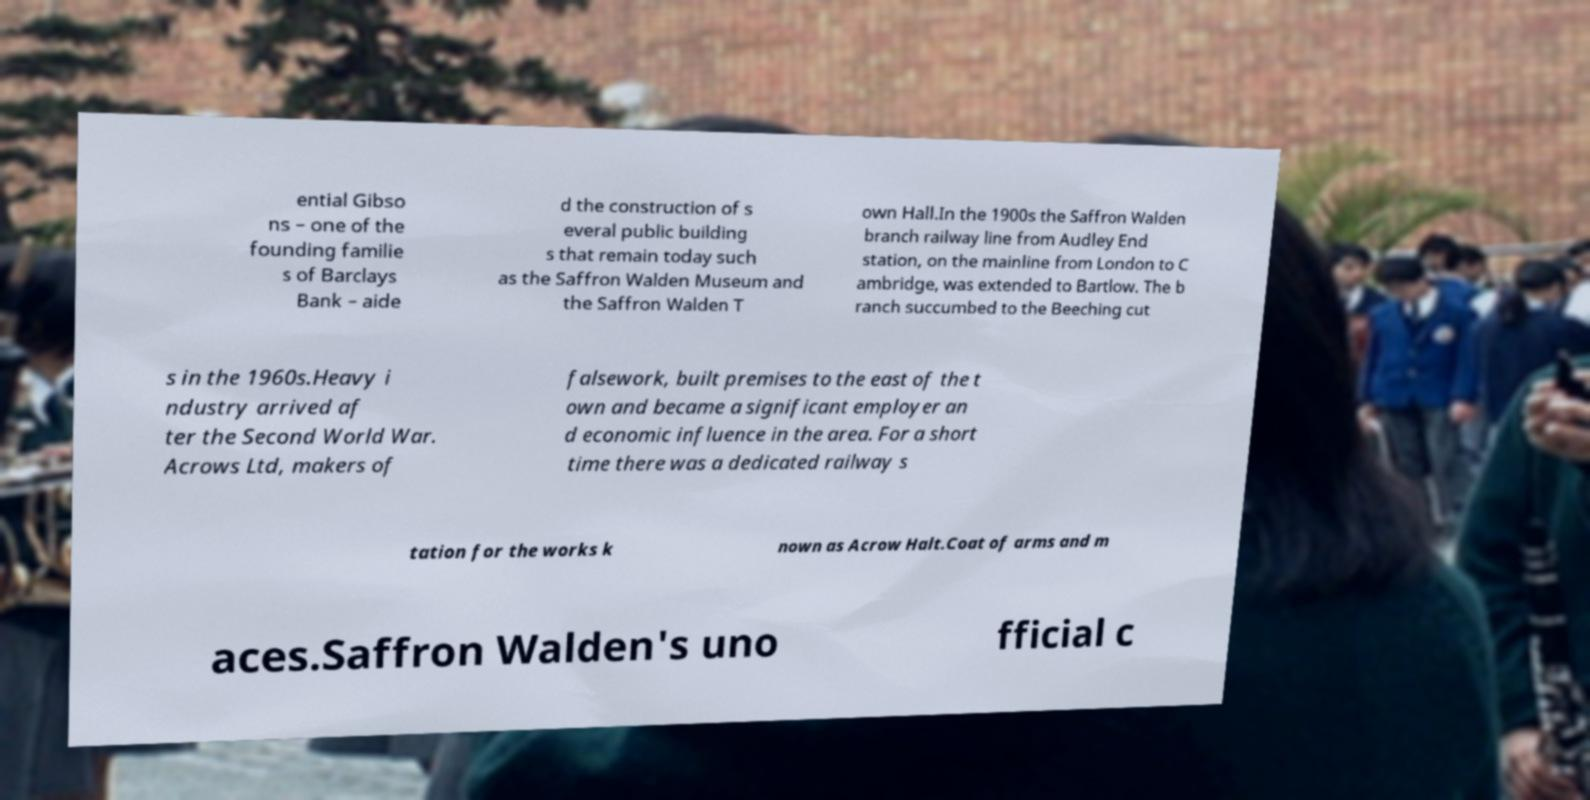Can you accurately transcribe the text from the provided image for me? ential Gibso ns – one of the founding familie s of Barclays Bank – aide d the construction of s everal public building s that remain today such as the Saffron Walden Museum and the Saffron Walden T own Hall.In the 1900s the Saffron Walden branch railway line from Audley End station, on the mainline from London to C ambridge, was extended to Bartlow. The b ranch succumbed to the Beeching cut s in the 1960s.Heavy i ndustry arrived af ter the Second World War. Acrows Ltd, makers of falsework, built premises to the east of the t own and became a significant employer an d economic influence in the area. For a short time there was a dedicated railway s tation for the works k nown as Acrow Halt.Coat of arms and m aces.Saffron Walden's uno fficial c 